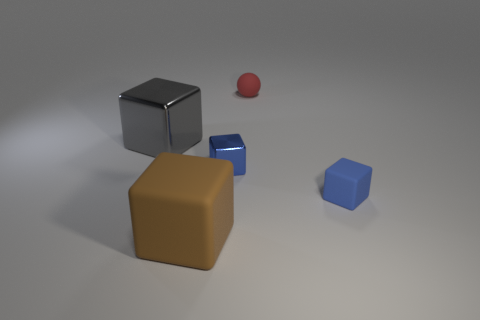Add 4 tiny red rubber things. How many objects exist? 9 Subtract all large brown matte cubes. How many cubes are left? 3 Subtract all gray cubes. How many cubes are left? 3 Subtract 0 blue balls. How many objects are left? 5 Subtract all blocks. How many objects are left? 1 Subtract all cyan blocks. Subtract all cyan balls. How many blocks are left? 4 Subtract all red cubes. How many purple spheres are left? 0 Subtract all big brown things. Subtract all big blocks. How many objects are left? 2 Add 2 tiny blue metallic objects. How many tiny blue metallic objects are left? 3 Add 2 blue matte things. How many blue matte things exist? 3 